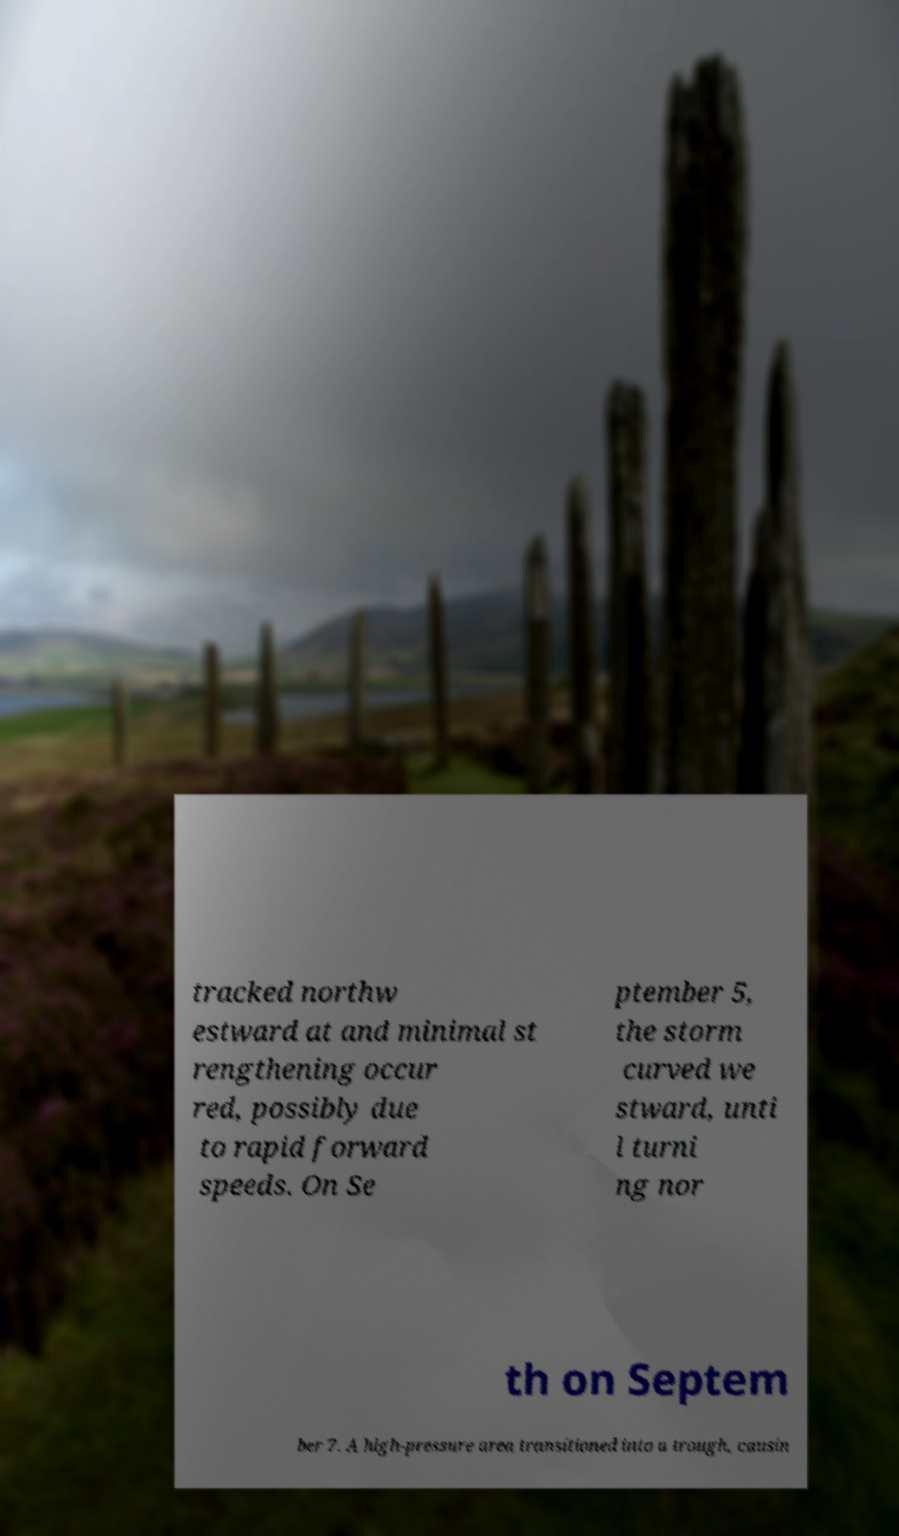Could you extract and type out the text from this image? tracked northw estward at and minimal st rengthening occur red, possibly due to rapid forward speeds. On Se ptember 5, the storm curved we stward, unti l turni ng nor th on Septem ber 7. A high-pressure area transitioned into a trough, causin 